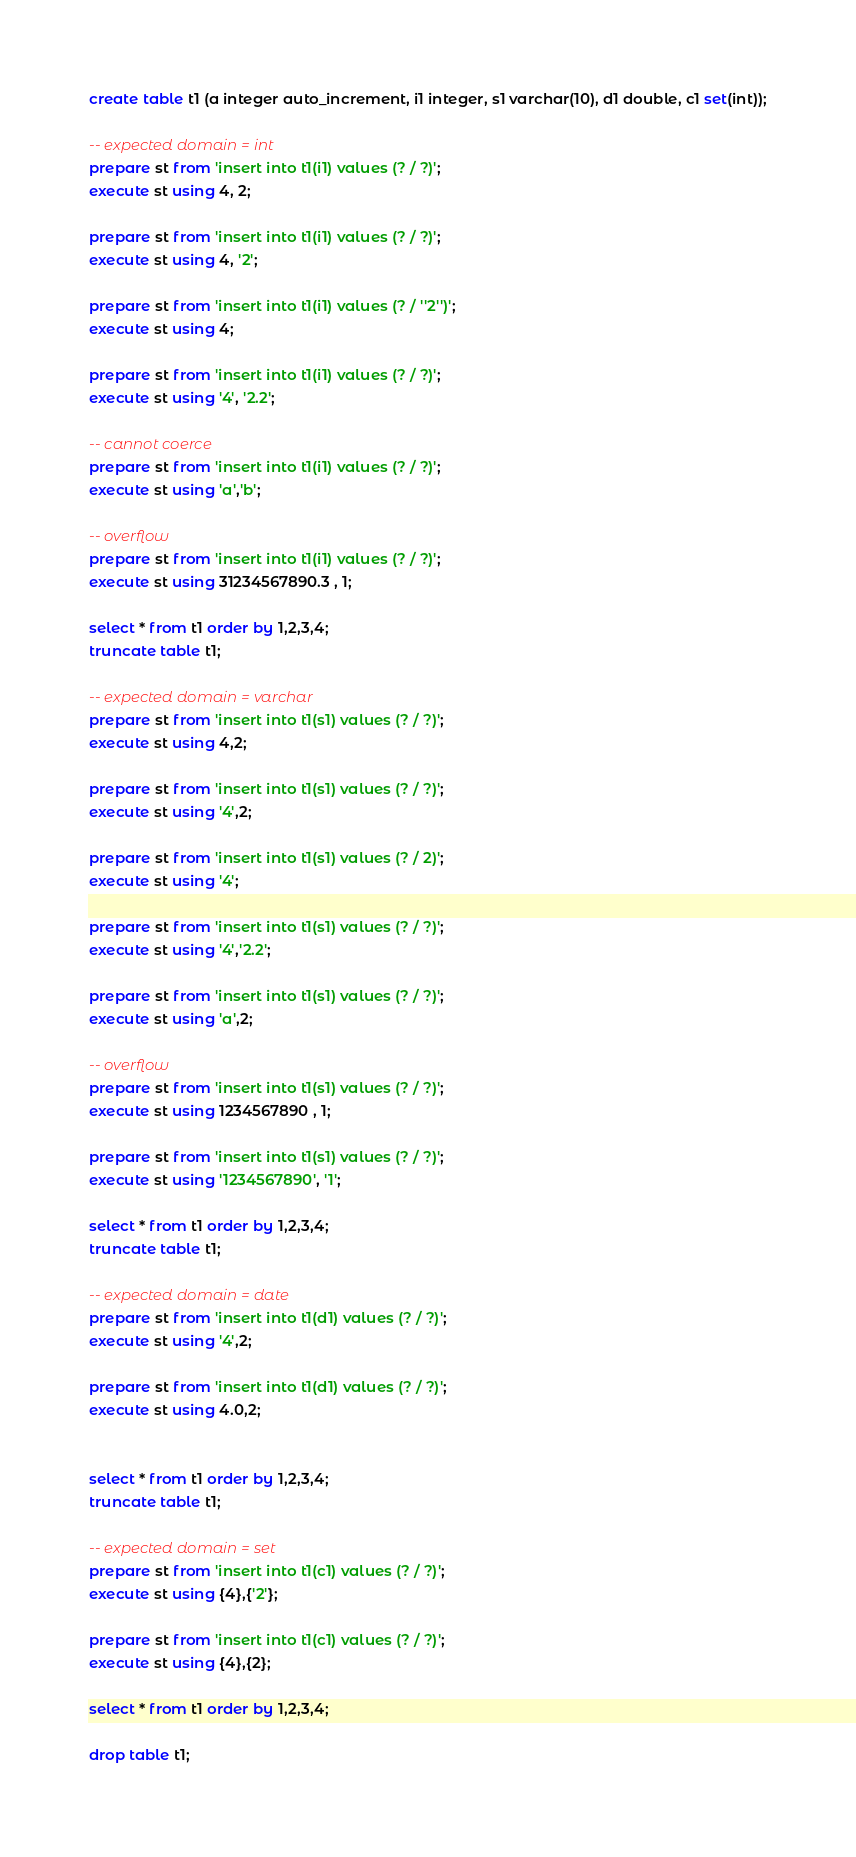<code> <loc_0><loc_0><loc_500><loc_500><_SQL_>create table t1 (a integer auto_increment, i1 integer, s1 varchar(10), d1 double, c1 set(int));

-- expected domain = int
prepare st from 'insert into t1(i1) values (? / ?)';
execute st using 4, 2;

prepare st from 'insert into t1(i1) values (? / ?)';
execute st using 4, '2';

prepare st from 'insert into t1(i1) values (? / ''2'')';
execute st using 4;

prepare st from 'insert into t1(i1) values (? / ?)';
execute st using '4', '2.2';

-- cannot coerce
prepare st from 'insert into t1(i1) values (? / ?)';
execute st using 'a','b';

-- overflow
prepare st from 'insert into t1(i1) values (? / ?)';
execute st using 31234567890.3 , 1;

select * from t1 order by 1,2,3,4;
truncate table t1;

-- expected domain = varchar
prepare st from 'insert into t1(s1) values (? / ?)';
execute st using 4,2;

prepare st from 'insert into t1(s1) values (? / ?)';
execute st using '4',2;

prepare st from 'insert into t1(s1) values (? / 2)';
execute st using '4';

prepare st from 'insert into t1(s1) values (? / ?)';
execute st using '4','2.2';

prepare st from 'insert into t1(s1) values (? / ?)';
execute st using 'a',2;

-- overflow
prepare st from 'insert into t1(s1) values (? / ?)';
execute st using 1234567890 , 1;

prepare st from 'insert into t1(s1) values (? / ?)';
execute st using '1234567890', '1';

select * from t1 order by 1,2,3,4;
truncate table t1;

-- expected domain = date
prepare st from 'insert into t1(d1) values (? / ?)';
execute st using '4',2;

prepare st from 'insert into t1(d1) values (? / ?)';
execute st using 4.0,2;


select * from t1 order by 1,2,3,4;
truncate table t1;

-- expected domain = set
prepare st from 'insert into t1(c1) values (? / ?)';
execute st using {4},{'2'};

prepare st from 'insert into t1(c1) values (? / ?)';
execute st using {4},{2};

select * from t1 order by 1,2,3,4;

drop table t1;
</code> 